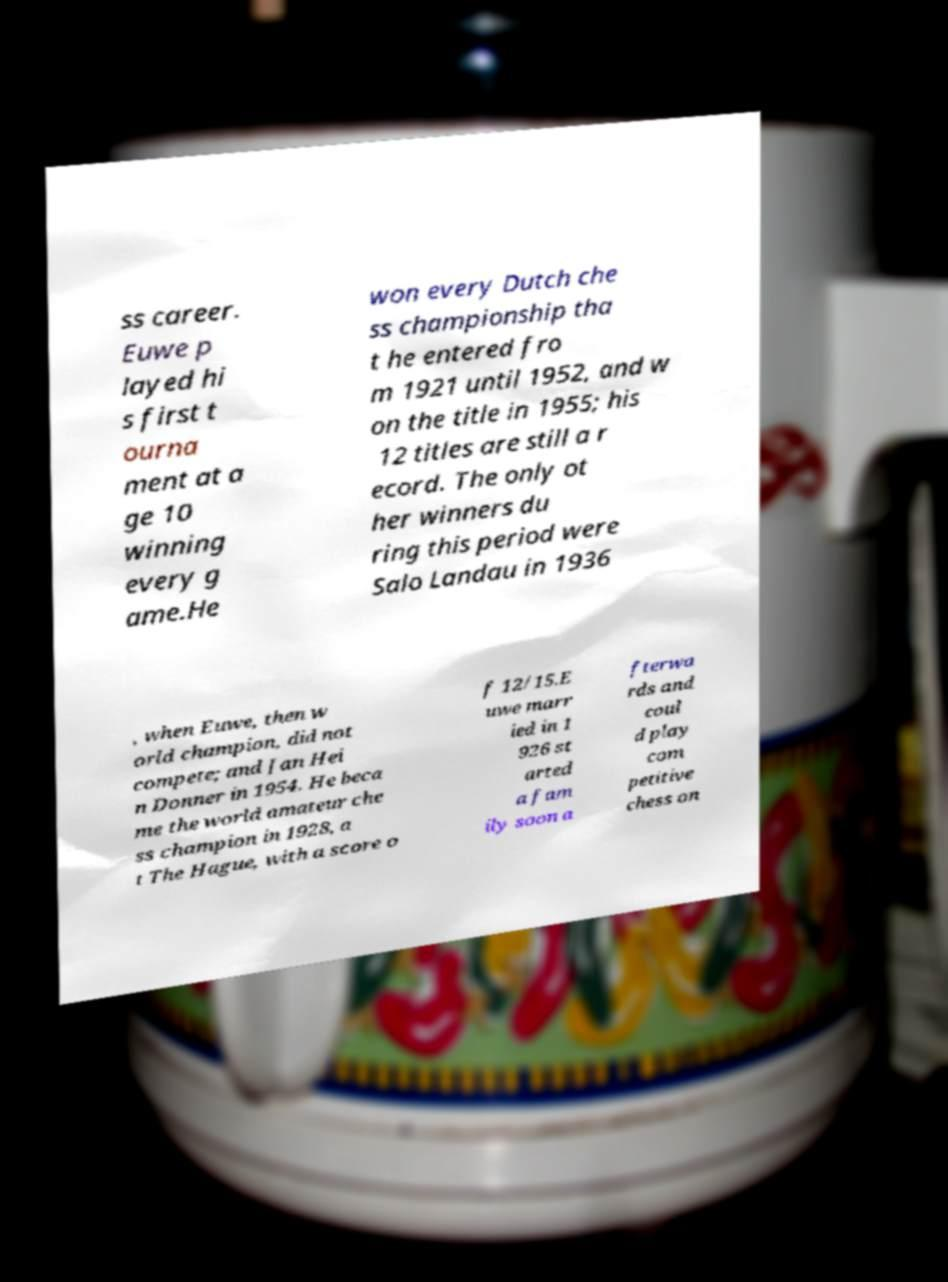There's text embedded in this image that I need extracted. Can you transcribe it verbatim? ss career. Euwe p layed hi s first t ourna ment at a ge 10 winning every g ame.He won every Dutch che ss championship tha t he entered fro m 1921 until 1952, and w on the title in 1955; his 12 titles are still a r ecord. The only ot her winners du ring this period were Salo Landau in 1936 , when Euwe, then w orld champion, did not compete; and Jan Hei n Donner in 1954. He beca me the world amateur che ss champion in 1928, a t The Hague, with a score o f 12/15.E uwe marr ied in 1 926 st arted a fam ily soon a fterwa rds and coul d play com petitive chess on 